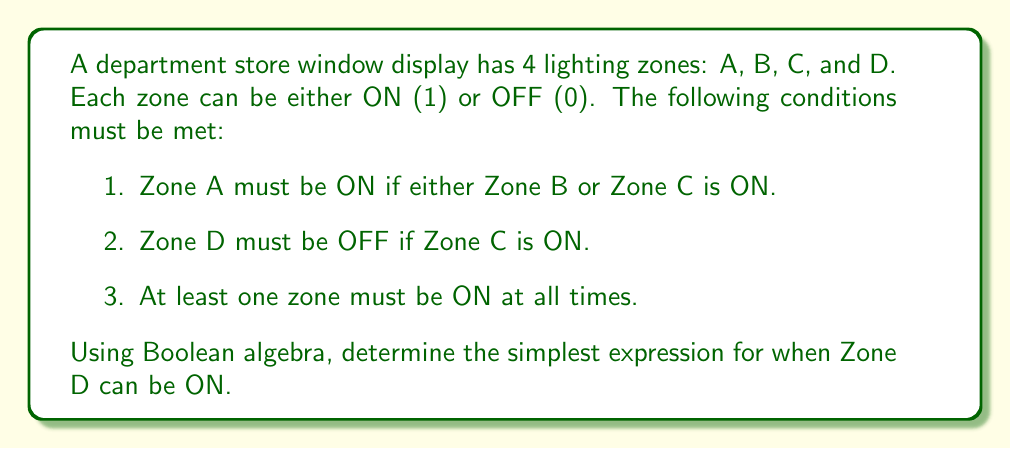Show me your answer to this math problem. Let's approach this step-by-step using Boolean algebra:

1. First, let's express the given conditions in Boolean algebra:
   - Condition 1: $A = B + C$ (where '+' represents OR)
   - Condition 2: $D = \overline{C}$ (where $\overline{C}$ represents NOT C)
   - Condition 3: $A + B + C + D = 1$ (at least one must be true)

2. We want to find when D can be ON, so we're looking for $D = 1$

3. From condition 2, we know that $D = 1$ only when $C = 0$

4. Now, let's consider the other conditions when $C = 0$:
   - From condition 1: $A = B + 0 = B$
   - From condition 3: $A + B + 0 + D = 1$, which simplifies to $A + B + D = 1$

5. Substituting $A = B$ from step 4 into $A + B + D = 1$:
   $B + B + D = 1$
   $B + D = 1$ (since $B + B = B$ in Boolean algebra)

6. This means that when $D = 1$, we must have $B = 0$ to satisfy the equation

Therefore, the simplest expression for when Zone D can be ON is:

$$D = \overline{B} \cdot \overline{C}$$

This means Zone D can be ON when both Zone B and Zone C are OFF.
Answer: $D = \overline{B} \cdot \overline{C}$ 